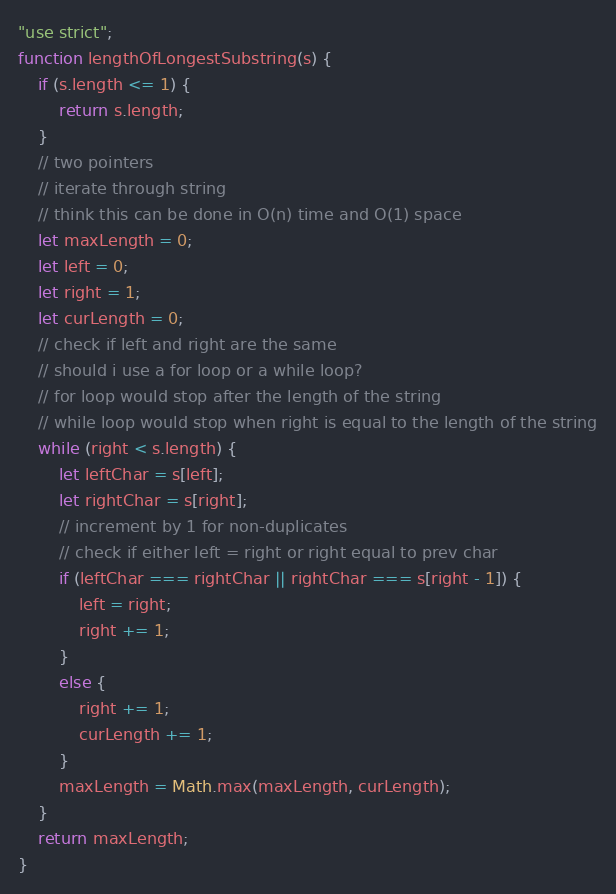<code> <loc_0><loc_0><loc_500><loc_500><_JavaScript_>"use strict";
function lengthOfLongestSubstring(s) {
    if (s.length <= 1) {
        return s.length;
    }
    // two pointers
    // iterate through string
    // think this can be done in O(n) time and O(1) space
    let maxLength = 0;
    let left = 0;
    let right = 1;
    let curLength = 0;
    // check if left and right are the same
    // should i use a for loop or a while loop?
    // for loop would stop after the length of the string
    // while loop would stop when right is equal to the length of the string
    while (right < s.length) {
        let leftChar = s[left];
        let rightChar = s[right];
        // increment by 1 for non-duplicates
        // check if either left = right or right equal to prev char
        if (leftChar === rightChar || rightChar === s[right - 1]) {
            left = right;
            right += 1;
        }
        else {
            right += 1;
            curLength += 1;
        }
        maxLength = Math.max(maxLength, curLength);
    }
    return maxLength;
}
</code> 